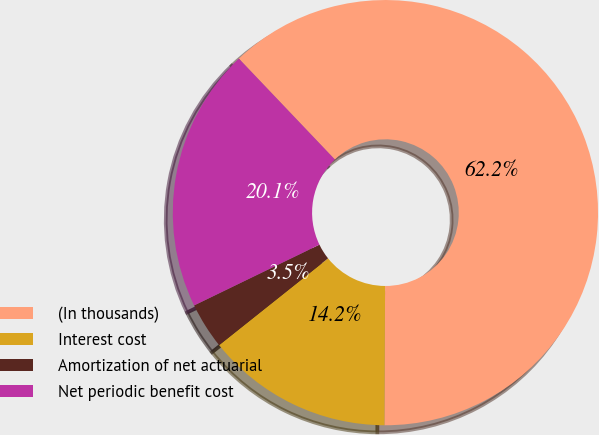Convert chart to OTSL. <chart><loc_0><loc_0><loc_500><loc_500><pie_chart><fcel>(In thousands)<fcel>Interest cost<fcel>Amortization of net actuarial<fcel>Net periodic benefit cost<nl><fcel>62.18%<fcel>14.22%<fcel>3.52%<fcel>20.08%<nl></chart> 